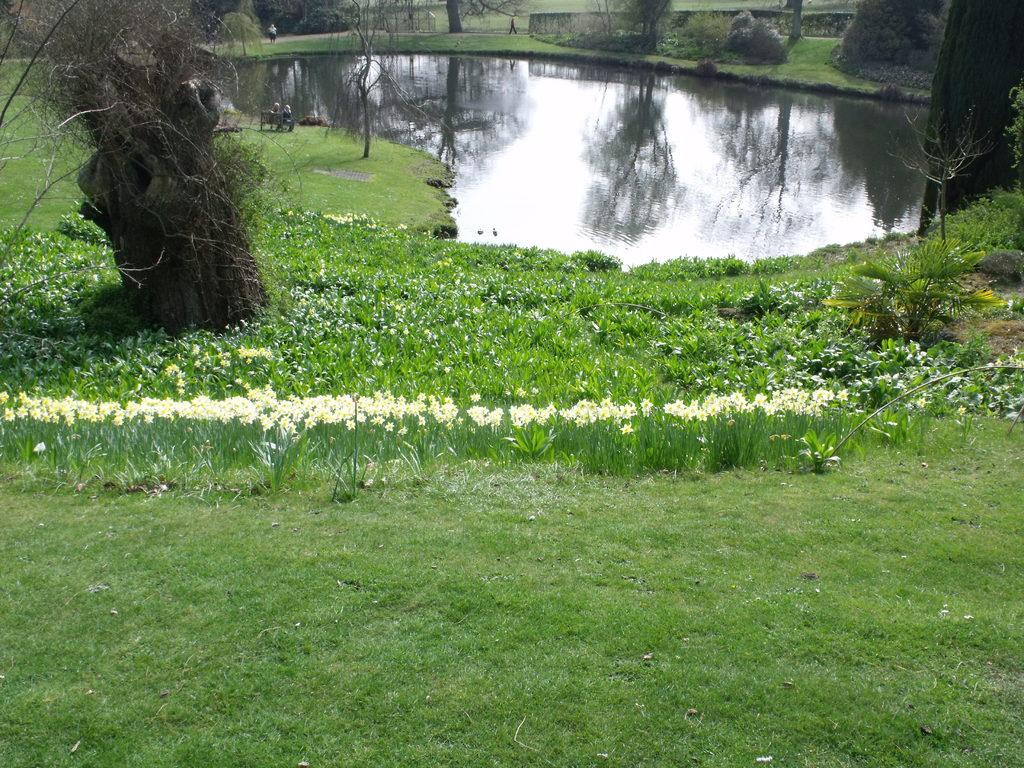What type of plants are in the middle of the image? There are flower plants in the middle of the image. What is located at the top of the image? There is a pond at the top of the image. What other natural elements can be seen in the image? There are trees in the image. How many pears are hanging from the trees in the image? There are no pears visible in the image; it features flower plants, a pond, and trees. 